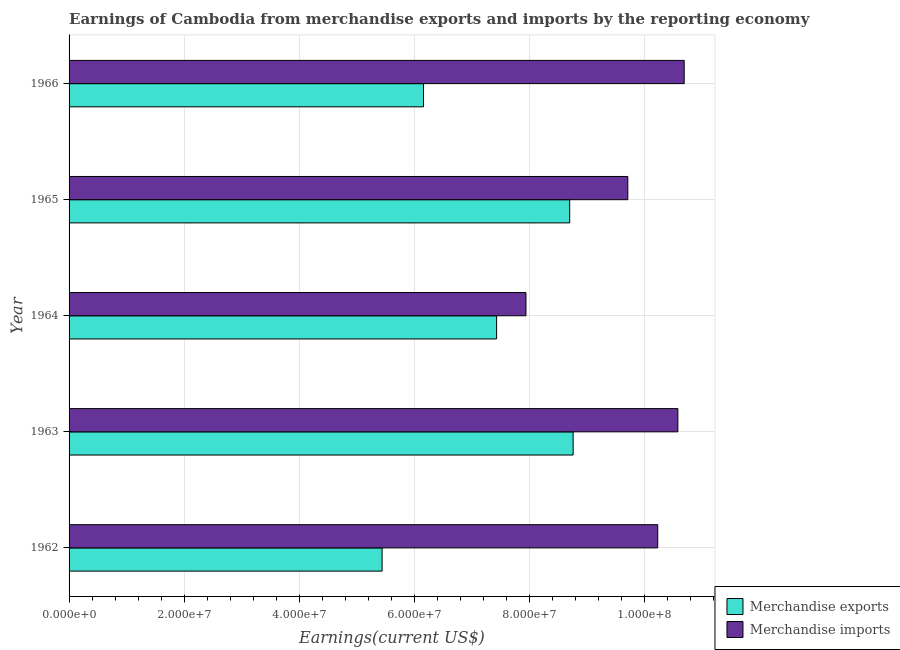Are the number of bars per tick equal to the number of legend labels?
Ensure brevity in your answer.  Yes. Are the number of bars on each tick of the Y-axis equal?
Ensure brevity in your answer.  Yes. How many bars are there on the 1st tick from the top?
Give a very brief answer. 2. How many bars are there on the 4th tick from the bottom?
Offer a terse response. 2. What is the label of the 1st group of bars from the top?
Offer a very short reply. 1966. What is the earnings from merchandise imports in 1964?
Provide a short and direct response. 7.94e+07. Across all years, what is the maximum earnings from merchandise imports?
Give a very brief answer. 1.07e+08. Across all years, what is the minimum earnings from merchandise imports?
Provide a short and direct response. 7.94e+07. In which year was the earnings from merchandise exports maximum?
Ensure brevity in your answer.  1963. In which year was the earnings from merchandise imports minimum?
Offer a terse response. 1964. What is the total earnings from merchandise exports in the graph?
Offer a terse response. 3.65e+08. What is the difference between the earnings from merchandise imports in 1964 and that in 1965?
Offer a very short reply. -1.77e+07. What is the difference between the earnings from merchandise imports in 1962 and the earnings from merchandise exports in 1963?
Make the answer very short. 1.47e+07. What is the average earnings from merchandise exports per year?
Your answer should be compact. 7.30e+07. In the year 1964, what is the difference between the earnings from merchandise imports and earnings from merchandise exports?
Provide a succinct answer. 5.10e+06. In how many years, is the earnings from merchandise exports greater than 28000000 US$?
Keep it short and to the point. 5. What is the ratio of the earnings from merchandise exports in 1963 to that in 1964?
Keep it short and to the point. 1.18. Is the earnings from merchandise imports in 1964 less than that in 1966?
Make the answer very short. Yes. Is the difference between the earnings from merchandise exports in 1962 and 1966 greater than the difference between the earnings from merchandise imports in 1962 and 1966?
Ensure brevity in your answer.  No. What is the difference between the highest and the lowest earnings from merchandise imports?
Ensure brevity in your answer.  2.75e+07. Is the sum of the earnings from merchandise imports in 1963 and 1966 greater than the maximum earnings from merchandise exports across all years?
Ensure brevity in your answer.  Yes. Are all the bars in the graph horizontal?
Your response must be concise. Yes. How many years are there in the graph?
Provide a short and direct response. 5. Does the graph contain any zero values?
Your answer should be compact. No. Does the graph contain grids?
Offer a terse response. Yes. Where does the legend appear in the graph?
Make the answer very short. Bottom right. How many legend labels are there?
Your answer should be very brief. 2. How are the legend labels stacked?
Offer a very short reply. Vertical. What is the title of the graph?
Make the answer very short. Earnings of Cambodia from merchandise exports and imports by the reporting economy. What is the label or title of the X-axis?
Provide a short and direct response. Earnings(current US$). What is the Earnings(current US$) of Merchandise exports in 1962?
Keep it short and to the point. 5.44e+07. What is the Earnings(current US$) in Merchandise imports in 1962?
Keep it short and to the point. 1.02e+08. What is the Earnings(current US$) in Merchandise exports in 1963?
Ensure brevity in your answer.  8.76e+07. What is the Earnings(current US$) in Merchandise imports in 1963?
Your response must be concise. 1.06e+08. What is the Earnings(current US$) in Merchandise exports in 1964?
Your answer should be compact. 7.43e+07. What is the Earnings(current US$) in Merchandise imports in 1964?
Your response must be concise. 7.94e+07. What is the Earnings(current US$) in Merchandise exports in 1965?
Provide a short and direct response. 8.70e+07. What is the Earnings(current US$) of Merchandise imports in 1965?
Your response must be concise. 9.71e+07. What is the Earnings(current US$) in Merchandise exports in 1966?
Offer a very short reply. 6.16e+07. What is the Earnings(current US$) in Merchandise imports in 1966?
Ensure brevity in your answer.  1.07e+08. Across all years, what is the maximum Earnings(current US$) in Merchandise exports?
Provide a succinct answer. 8.76e+07. Across all years, what is the maximum Earnings(current US$) in Merchandise imports?
Provide a succinct answer. 1.07e+08. Across all years, what is the minimum Earnings(current US$) in Merchandise exports?
Provide a short and direct response. 5.44e+07. Across all years, what is the minimum Earnings(current US$) of Merchandise imports?
Ensure brevity in your answer.  7.94e+07. What is the total Earnings(current US$) in Merchandise exports in the graph?
Give a very brief answer. 3.65e+08. What is the total Earnings(current US$) in Merchandise imports in the graph?
Your answer should be compact. 4.92e+08. What is the difference between the Earnings(current US$) of Merchandise exports in 1962 and that in 1963?
Provide a short and direct response. -3.32e+07. What is the difference between the Earnings(current US$) of Merchandise imports in 1962 and that in 1963?
Make the answer very short. -3.50e+06. What is the difference between the Earnings(current US$) of Merchandise exports in 1962 and that in 1964?
Give a very brief answer. -1.99e+07. What is the difference between the Earnings(current US$) in Merchandise imports in 1962 and that in 1964?
Offer a terse response. 2.29e+07. What is the difference between the Earnings(current US$) in Merchandise exports in 1962 and that in 1965?
Your answer should be very brief. -3.26e+07. What is the difference between the Earnings(current US$) of Merchandise imports in 1962 and that in 1965?
Offer a terse response. 5.20e+06. What is the difference between the Earnings(current US$) of Merchandise exports in 1962 and that in 1966?
Your response must be concise. -7.20e+06. What is the difference between the Earnings(current US$) in Merchandise imports in 1962 and that in 1966?
Keep it short and to the point. -4.60e+06. What is the difference between the Earnings(current US$) of Merchandise exports in 1963 and that in 1964?
Keep it short and to the point. 1.33e+07. What is the difference between the Earnings(current US$) in Merchandise imports in 1963 and that in 1964?
Provide a short and direct response. 2.64e+07. What is the difference between the Earnings(current US$) of Merchandise exports in 1963 and that in 1965?
Provide a succinct answer. 6.00e+05. What is the difference between the Earnings(current US$) of Merchandise imports in 1963 and that in 1965?
Ensure brevity in your answer.  8.70e+06. What is the difference between the Earnings(current US$) of Merchandise exports in 1963 and that in 1966?
Provide a succinct answer. 2.60e+07. What is the difference between the Earnings(current US$) of Merchandise imports in 1963 and that in 1966?
Your response must be concise. -1.10e+06. What is the difference between the Earnings(current US$) in Merchandise exports in 1964 and that in 1965?
Give a very brief answer. -1.27e+07. What is the difference between the Earnings(current US$) of Merchandise imports in 1964 and that in 1965?
Provide a short and direct response. -1.77e+07. What is the difference between the Earnings(current US$) in Merchandise exports in 1964 and that in 1966?
Provide a succinct answer. 1.27e+07. What is the difference between the Earnings(current US$) of Merchandise imports in 1964 and that in 1966?
Give a very brief answer. -2.75e+07. What is the difference between the Earnings(current US$) of Merchandise exports in 1965 and that in 1966?
Your response must be concise. 2.54e+07. What is the difference between the Earnings(current US$) in Merchandise imports in 1965 and that in 1966?
Offer a very short reply. -9.80e+06. What is the difference between the Earnings(current US$) in Merchandise exports in 1962 and the Earnings(current US$) in Merchandise imports in 1963?
Make the answer very short. -5.14e+07. What is the difference between the Earnings(current US$) of Merchandise exports in 1962 and the Earnings(current US$) of Merchandise imports in 1964?
Make the answer very short. -2.50e+07. What is the difference between the Earnings(current US$) in Merchandise exports in 1962 and the Earnings(current US$) in Merchandise imports in 1965?
Provide a short and direct response. -4.27e+07. What is the difference between the Earnings(current US$) in Merchandise exports in 1962 and the Earnings(current US$) in Merchandise imports in 1966?
Make the answer very short. -5.25e+07. What is the difference between the Earnings(current US$) in Merchandise exports in 1963 and the Earnings(current US$) in Merchandise imports in 1964?
Give a very brief answer. 8.20e+06. What is the difference between the Earnings(current US$) in Merchandise exports in 1963 and the Earnings(current US$) in Merchandise imports in 1965?
Your answer should be compact. -9.50e+06. What is the difference between the Earnings(current US$) in Merchandise exports in 1963 and the Earnings(current US$) in Merchandise imports in 1966?
Provide a succinct answer. -1.93e+07. What is the difference between the Earnings(current US$) in Merchandise exports in 1964 and the Earnings(current US$) in Merchandise imports in 1965?
Offer a terse response. -2.28e+07. What is the difference between the Earnings(current US$) of Merchandise exports in 1964 and the Earnings(current US$) of Merchandise imports in 1966?
Provide a succinct answer. -3.26e+07. What is the difference between the Earnings(current US$) of Merchandise exports in 1965 and the Earnings(current US$) of Merchandise imports in 1966?
Offer a very short reply. -1.99e+07. What is the average Earnings(current US$) in Merchandise exports per year?
Give a very brief answer. 7.30e+07. What is the average Earnings(current US$) of Merchandise imports per year?
Your answer should be compact. 9.83e+07. In the year 1962, what is the difference between the Earnings(current US$) in Merchandise exports and Earnings(current US$) in Merchandise imports?
Your answer should be compact. -4.79e+07. In the year 1963, what is the difference between the Earnings(current US$) of Merchandise exports and Earnings(current US$) of Merchandise imports?
Give a very brief answer. -1.82e+07. In the year 1964, what is the difference between the Earnings(current US$) of Merchandise exports and Earnings(current US$) of Merchandise imports?
Your answer should be compact. -5.10e+06. In the year 1965, what is the difference between the Earnings(current US$) in Merchandise exports and Earnings(current US$) in Merchandise imports?
Provide a succinct answer. -1.01e+07. In the year 1966, what is the difference between the Earnings(current US$) of Merchandise exports and Earnings(current US$) of Merchandise imports?
Your answer should be compact. -4.53e+07. What is the ratio of the Earnings(current US$) in Merchandise exports in 1962 to that in 1963?
Provide a succinct answer. 0.62. What is the ratio of the Earnings(current US$) of Merchandise imports in 1962 to that in 1963?
Offer a terse response. 0.97. What is the ratio of the Earnings(current US$) in Merchandise exports in 1962 to that in 1964?
Keep it short and to the point. 0.73. What is the ratio of the Earnings(current US$) of Merchandise imports in 1962 to that in 1964?
Provide a succinct answer. 1.29. What is the ratio of the Earnings(current US$) of Merchandise exports in 1962 to that in 1965?
Your response must be concise. 0.63. What is the ratio of the Earnings(current US$) in Merchandise imports in 1962 to that in 1965?
Give a very brief answer. 1.05. What is the ratio of the Earnings(current US$) of Merchandise exports in 1962 to that in 1966?
Offer a terse response. 0.88. What is the ratio of the Earnings(current US$) of Merchandise exports in 1963 to that in 1964?
Offer a very short reply. 1.18. What is the ratio of the Earnings(current US$) in Merchandise imports in 1963 to that in 1964?
Keep it short and to the point. 1.33. What is the ratio of the Earnings(current US$) of Merchandise exports in 1963 to that in 1965?
Offer a very short reply. 1.01. What is the ratio of the Earnings(current US$) in Merchandise imports in 1963 to that in 1965?
Your answer should be very brief. 1.09. What is the ratio of the Earnings(current US$) of Merchandise exports in 1963 to that in 1966?
Give a very brief answer. 1.42. What is the ratio of the Earnings(current US$) in Merchandise imports in 1963 to that in 1966?
Offer a very short reply. 0.99. What is the ratio of the Earnings(current US$) in Merchandise exports in 1964 to that in 1965?
Ensure brevity in your answer.  0.85. What is the ratio of the Earnings(current US$) in Merchandise imports in 1964 to that in 1965?
Ensure brevity in your answer.  0.82. What is the ratio of the Earnings(current US$) of Merchandise exports in 1964 to that in 1966?
Make the answer very short. 1.21. What is the ratio of the Earnings(current US$) of Merchandise imports in 1964 to that in 1966?
Provide a short and direct response. 0.74. What is the ratio of the Earnings(current US$) in Merchandise exports in 1965 to that in 1966?
Your response must be concise. 1.41. What is the ratio of the Earnings(current US$) of Merchandise imports in 1965 to that in 1966?
Give a very brief answer. 0.91. What is the difference between the highest and the second highest Earnings(current US$) in Merchandise exports?
Your answer should be very brief. 6.00e+05. What is the difference between the highest and the second highest Earnings(current US$) of Merchandise imports?
Your answer should be very brief. 1.10e+06. What is the difference between the highest and the lowest Earnings(current US$) in Merchandise exports?
Ensure brevity in your answer.  3.32e+07. What is the difference between the highest and the lowest Earnings(current US$) in Merchandise imports?
Your answer should be very brief. 2.75e+07. 